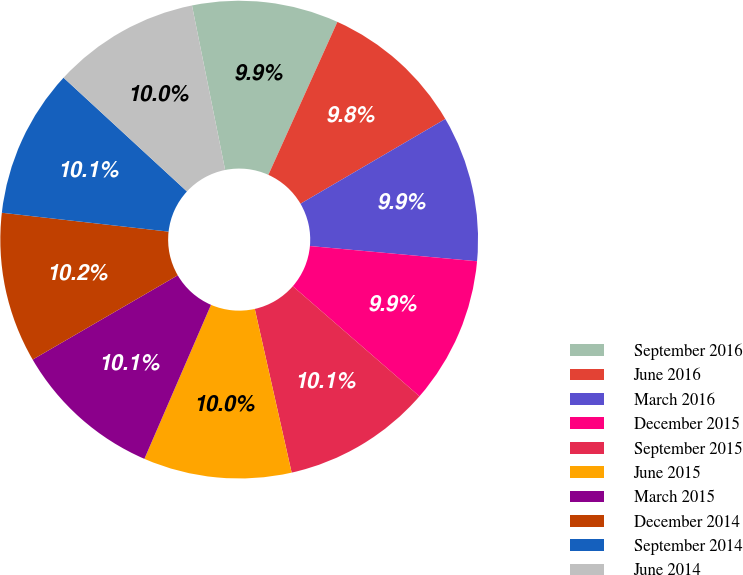Convert chart to OTSL. <chart><loc_0><loc_0><loc_500><loc_500><pie_chart><fcel>September 2016<fcel>June 2016<fcel>March 2016<fcel>December 2015<fcel>September 2015<fcel>June 2015<fcel>March 2015<fcel>December 2014<fcel>September 2014<fcel>June 2014<nl><fcel>9.91%<fcel>9.83%<fcel>9.87%<fcel>9.94%<fcel>10.09%<fcel>10.02%<fcel>10.13%<fcel>10.17%<fcel>10.06%<fcel>9.98%<nl></chart> 